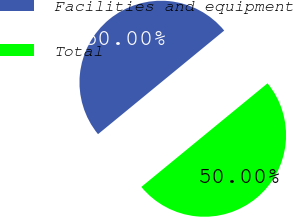Convert chart to OTSL. <chart><loc_0><loc_0><loc_500><loc_500><pie_chart><fcel>Facilities and equipment<fcel>Total<nl><fcel>50.0%<fcel>50.0%<nl></chart> 